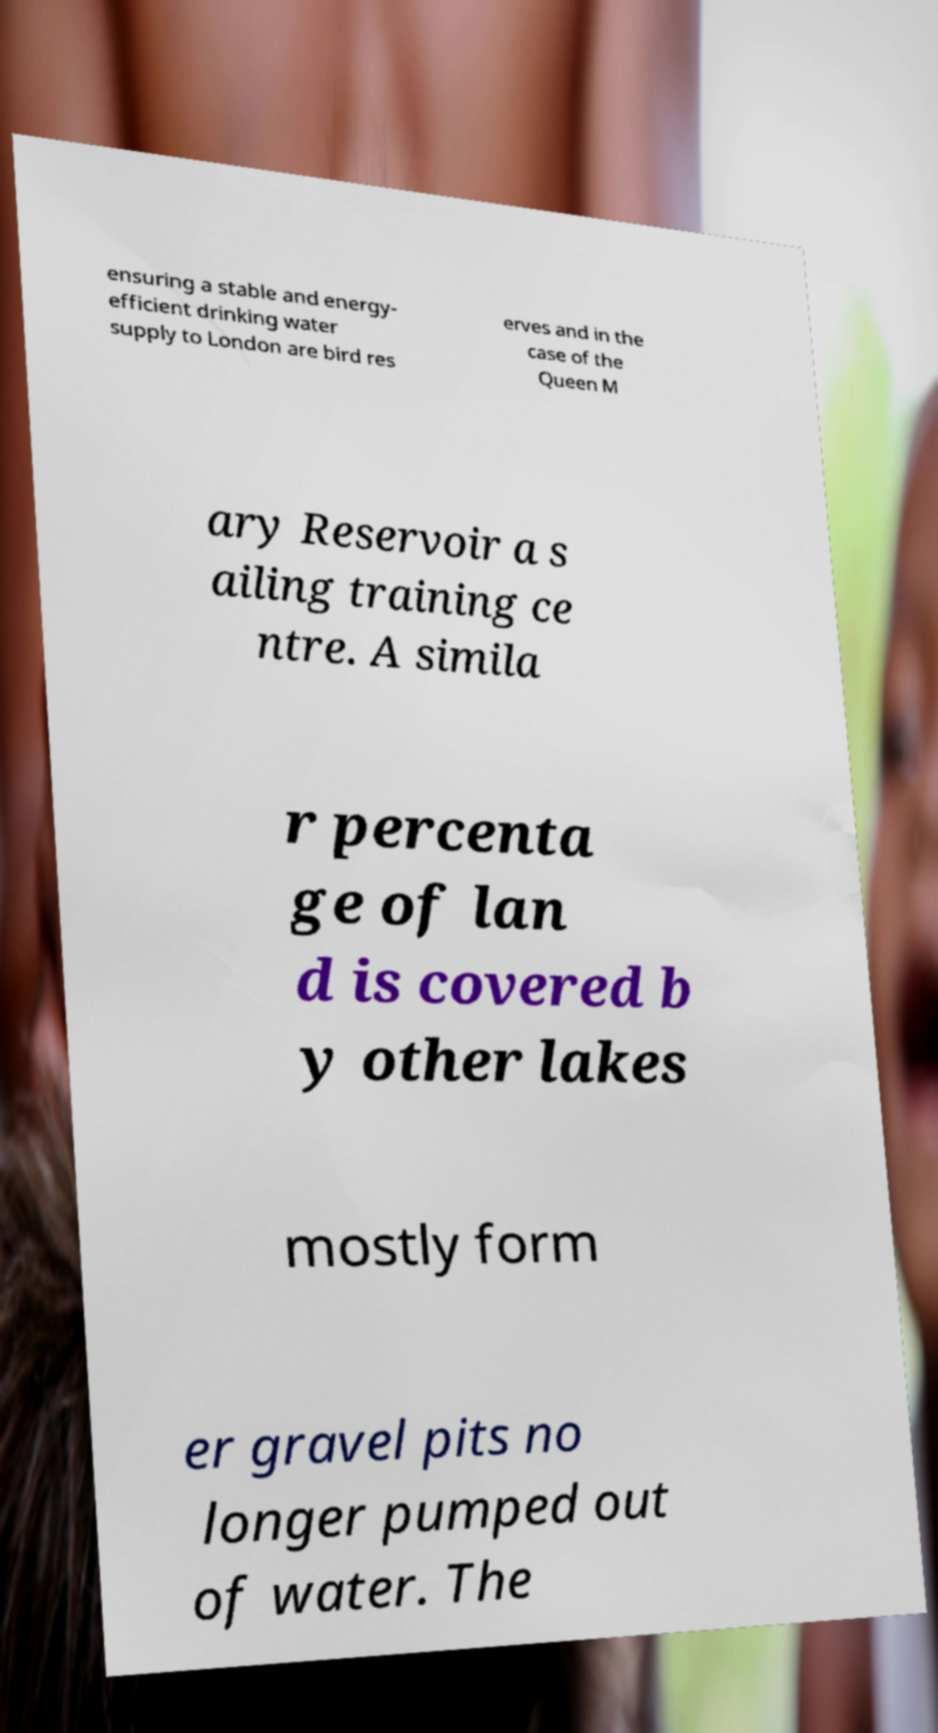There's text embedded in this image that I need extracted. Can you transcribe it verbatim? ensuring a stable and energy- efficient drinking water supply to London are bird res erves and in the case of the Queen M ary Reservoir a s ailing training ce ntre. A simila r percenta ge of lan d is covered b y other lakes mostly form er gravel pits no longer pumped out of water. The 